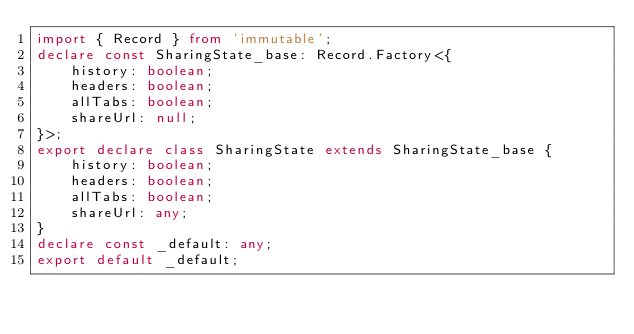Convert code to text. <code><loc_0><loc_0><loc_500><loc_500><_TypeScript_>import { Record } from 'immutable';
declare const SharingState_base: Record.Factory<{
    history: boolean;
    headers: boolean;
    allTabs: boolean;
    shareUrl: null;
}>;
export declare class SharingState extends SharingState_base {
    history: boolean;
    headers: boolean;
    allTabs: boolean;
    shareUrl: any;
}
declare const _default: any;
export default _default;
</code> 